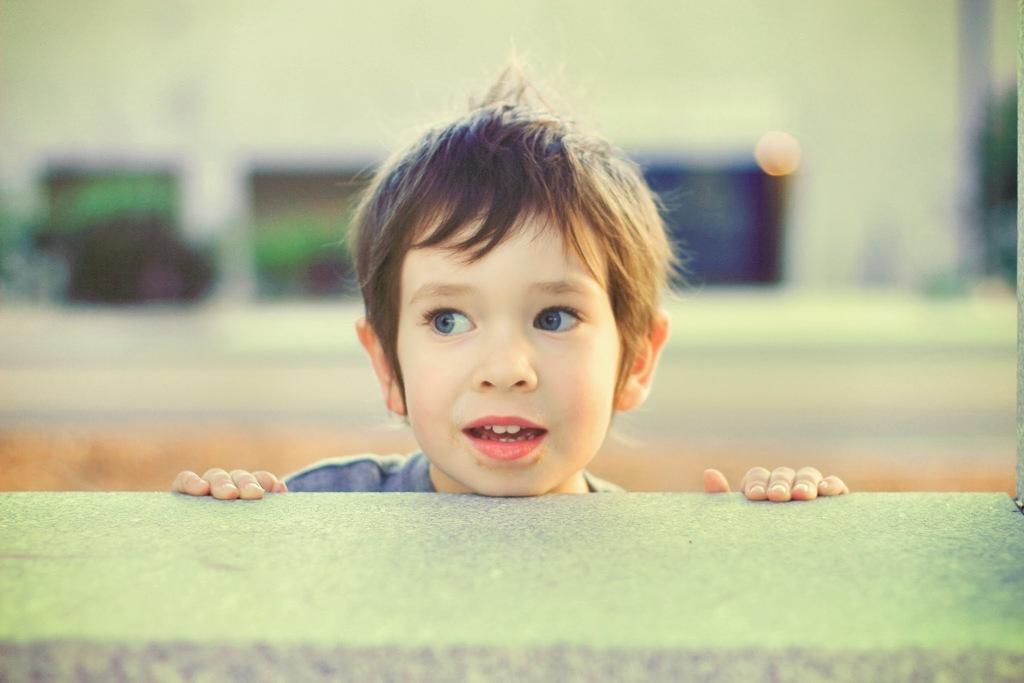In one or two sentences, can you explain what this image depicts? In this image we can see a child in the middle. And we can see the wall. And the background is blurry. 